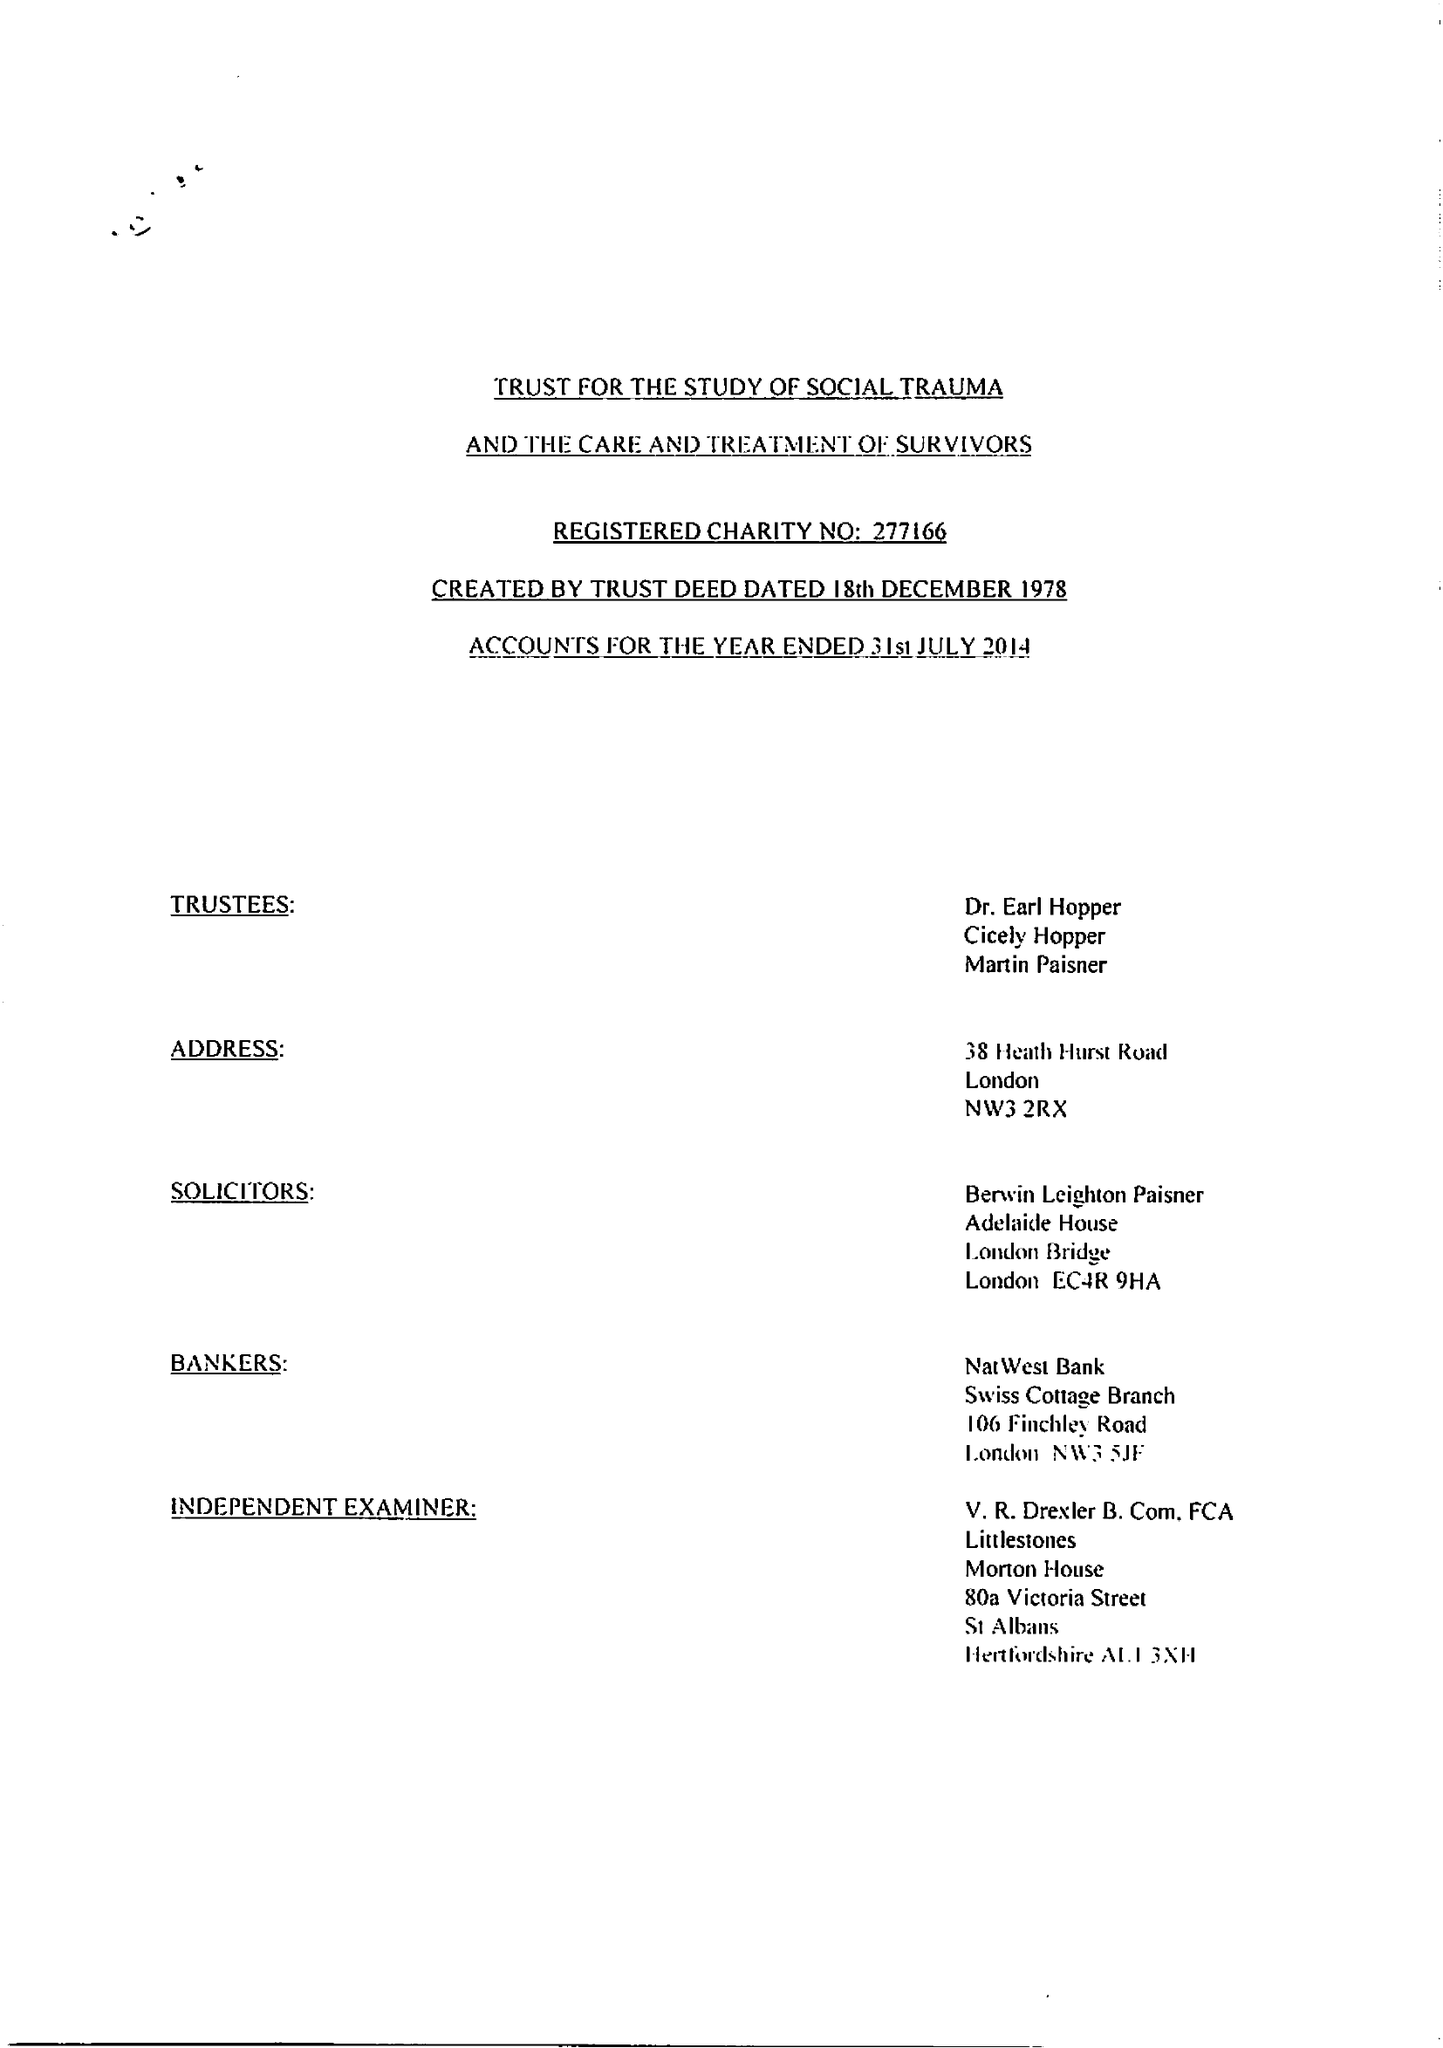What is the value for the address__postcode?
Answer the question using a single word or phrase. NW3 2RX 